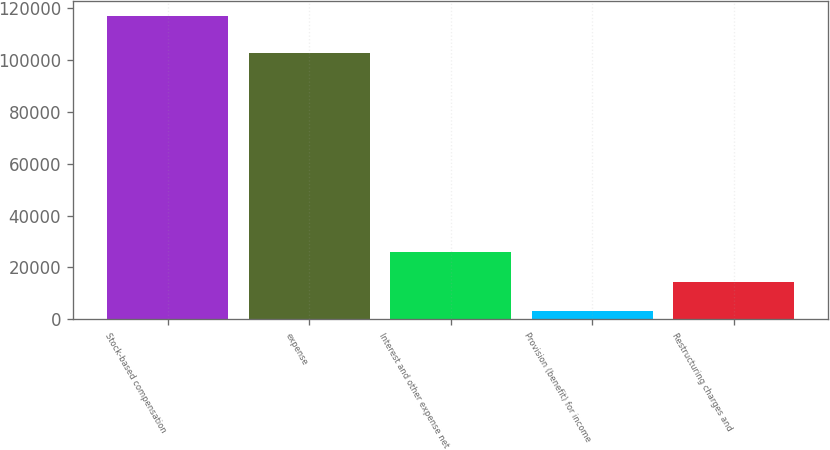Convert chart. <chart><loc_0><loc_0><loc_500><loc_500><bar_chart><fcel>Stock-based compensation<fcel>expense<fcel>Interest and other expense net<fcel>Provision (benefit) for income<fcel>Restructuring charges and<nl><fcel>116997<fcel>102792<fcel>25954.6<fcel>3194<fcel>14574.3<nl></chart> 